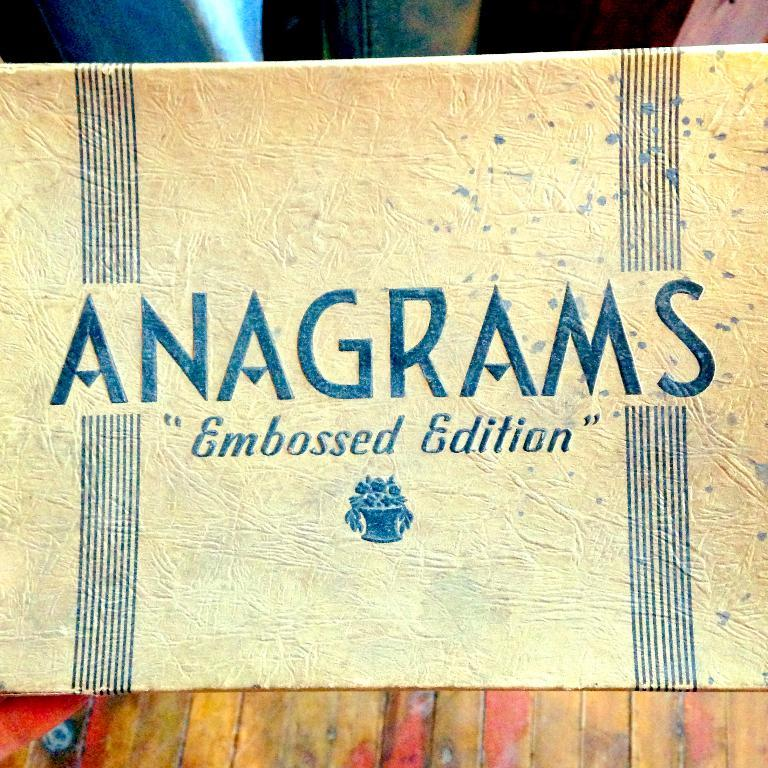<image>
Present a compact description of the photo's key features. a close up of an Anagrams card Embossed Edition 